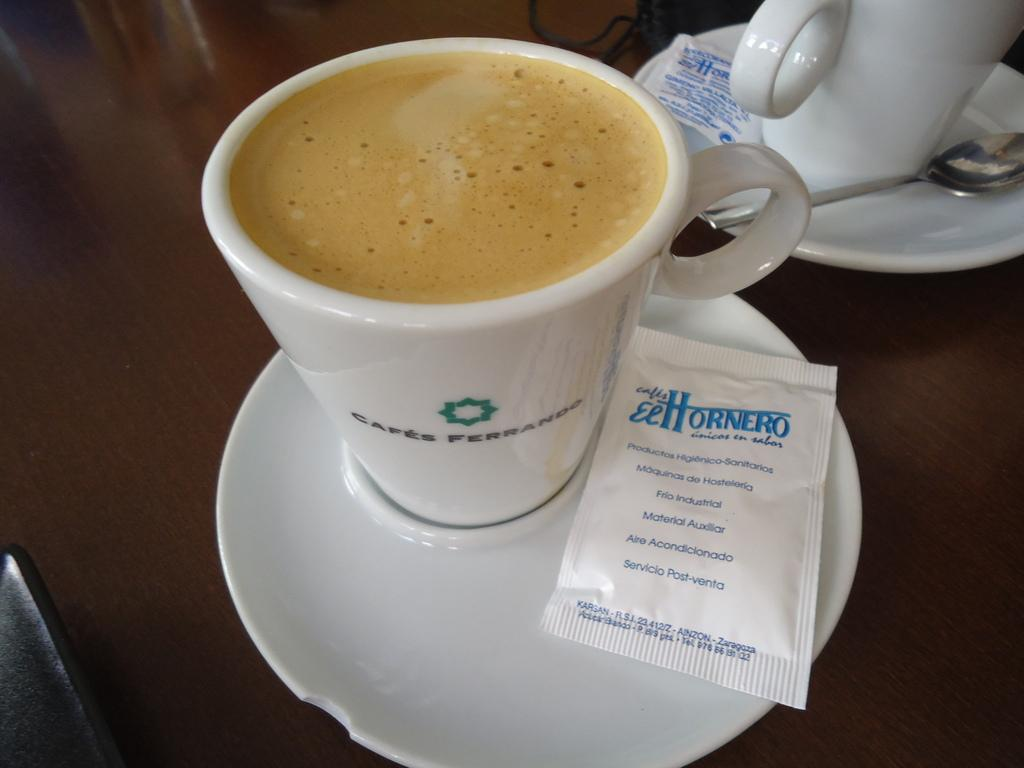What objects are placed on the wooden platform in the image? There are cups, saucers, spoons, and packets on the wooden platform. Can you describe the utensils present on the wooden platform? There are spoons on the wooden platform. What type of containers are present on the wooden platform? There are cups and packets on the wooden platform. Are there any saucers on the wooden platform? Yes, there are saucers on the wooden platform. Can you see a lake in the background of the image? There is no lake visible in the image; it only shows objects on a wooden platform. 